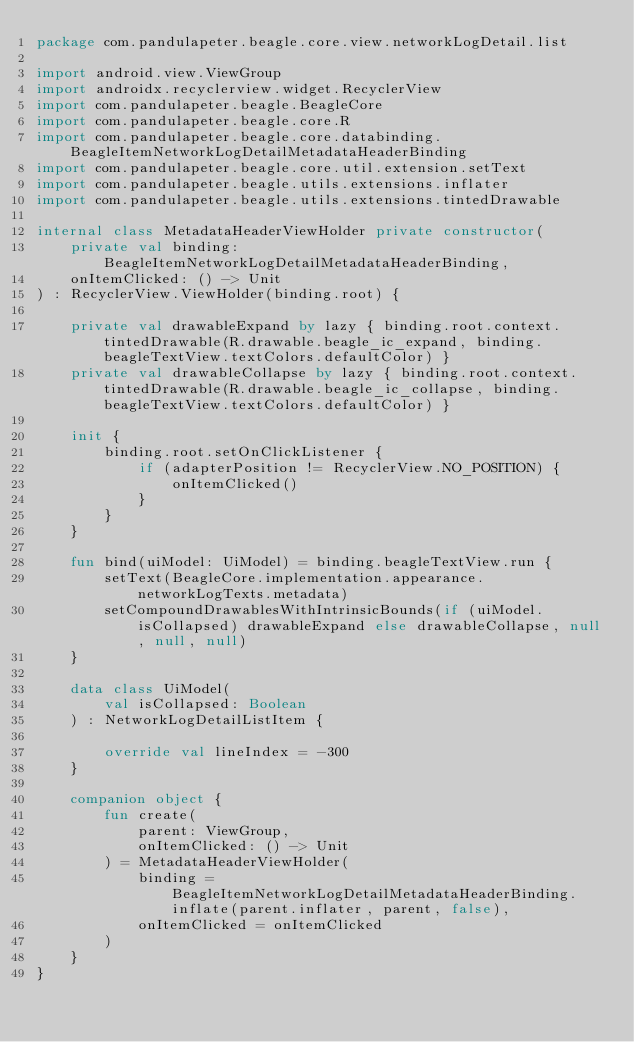<code> <loc_0><loc_0><loc_500><loc_500><_Kotlin_>package com.pandulapeter.beagle.core.view.networkLogDetail.list

import android.view.ViewGroup
import androidx.recyclerview.widget.RecyclerView
import com.pandulapeter.beagle.BeagleCore
import com.pandulapeter.beagle.core.R
import com.pandulapeter.beagle.core.databinding.BeagleItemNetworkLogDetailMetadataHeaderBinding
import com.pandulapeter.beagle.core.util.extension.setText
import com.pandulapeter.beagle.utils.extensions.inflater
import com.pandulapeter.beagle.utils.extensions.tintedDrawable

internal class MetadataHeaderViewHolder private constructor(
    private val binding: BeagleItemNetworkLogDetailMetadataHeaderBinding,
    onItemClicked: () -> Unit
) : RecyclerView.ViewHolder(binding.root) {

    private val drawableExpand by lazy { binding.root.context.tintedDrawable(R.drawable.beagle_ic_expand, binding.beagleTextView.textColors.defaultColor) }
    private val drawableCollapse by lazy { binding.root.context.tintedDrawable(R.drawable.beagle_ic_collapse, binding.beagleTextView.textColors.defaultColor) }

    init {
        binding.root.setOnClickListener {
            if (adapterPosition != RecyclerView.NO_POSITION) {
                onItemClicked()
            }
        }
    }

    fun bind(uiModel: UiModel) = binding.beagleTextView.run {
        setText(BeagleCore.implementation.appearance.networkLogTexts.metadata)
        setCompoundDrawablesWithIntrinsicBounds(if (uiModel.isCollapsed) drawableExpand else drawableCollapse, null, null, null)
    }

    data class UiModel(
        val isCollapsed: Boolean
    ) : NetworkLogDetailListItem {

        override val lineIndex = -300
    }

    companion object {
        fun create(
            parent: ViewGroup,
            onItemClicked: () -> Unit
        ) = MetadataHeaderViewHolder(
            binding = BeagleItemNetworkLogDetailMetadataHeaderBinding.inflate(parent.inflater, parent, false),
            onItemClicked = onItemClicked
        )
    }
}</code> 